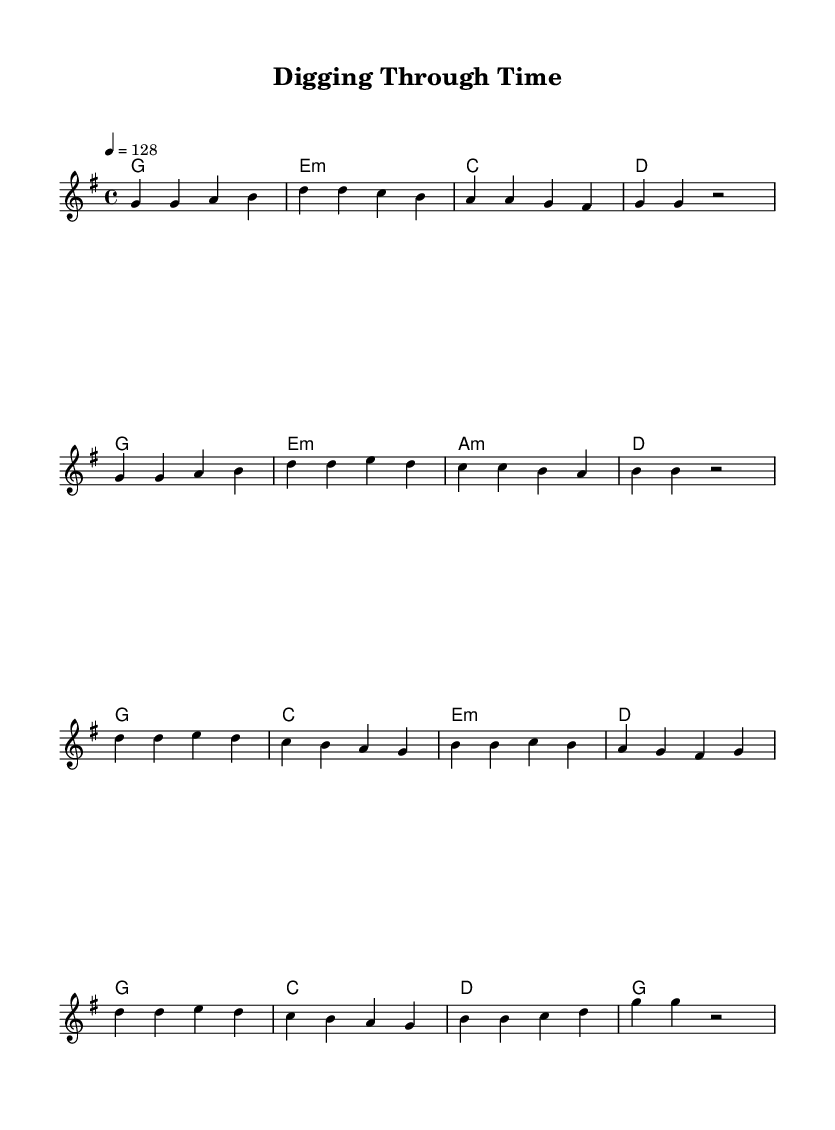What is the key signature of this music? The key signature indicated is G major, which has one sharp (F#).
Answer: G major What is the time signature of this music? The time signature displayed at the beginning is 4/4, meaning there are four beats in each measure and the quarter note gets one beat.
Answer: 4/4 What is the tempo marking of this music? The tempo marking in the sheet is 128 beats per minute, indicated by the tempo statement "4 = 128".
Answer: 128 How many measures are in the verse section? The verse section contains a total of 8 measures, as each line of the melody segment shows a grouping of 4 measures, totaling 2 lines.
Answer: 8 What chords are used in the chorus? The chords in the chorus are G, C, E minor, and D, as shown in the chord progression written alongside the melody part for the chorus.
Answer: G, C, E minor, D What theme is expressed in the lyrics of this K-Pop song? The lyrics focus on archival research and the importance of discovering history, as referenced in phrases like "digging through the archives" and "bringing history to light."
Answer: Archival research How does this music reflect K-Pop characteristics? The music features an upbeat tempo, catchy melody, and structured sections typical in K-Pop songs, along with engaging themes like historical exploration, common in the genre.
Answer: Upbeat, catchy, structured 